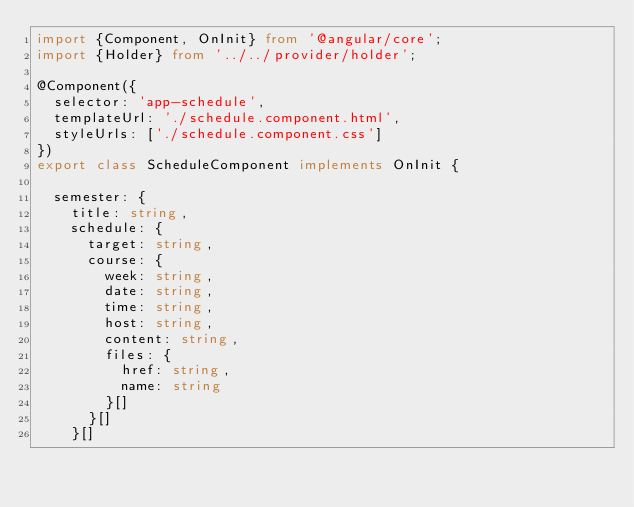Convert code to text. <code><loc_0><loc_0><loc_500><loc_500><_TypeScript_>import {Component, OnInit} from '@angular/core';
import {Holder} from '../../provider/holder';

@Component({
  selector: 'app-schedule',
  templateUrl: './schedule.component.html',
  styleUrls: ['./schedule.component.css']
})
export class ScheduleComponent implements OnInit {

  semester: {
    title: string,
    schedule: {
      target: string,
      course: {
        week: string,
        date: string,
        time: string,
        host: string,
        content: string,
        files: {
          href: string,
          name: string
        }[]
      }[]
    }[]</code> 